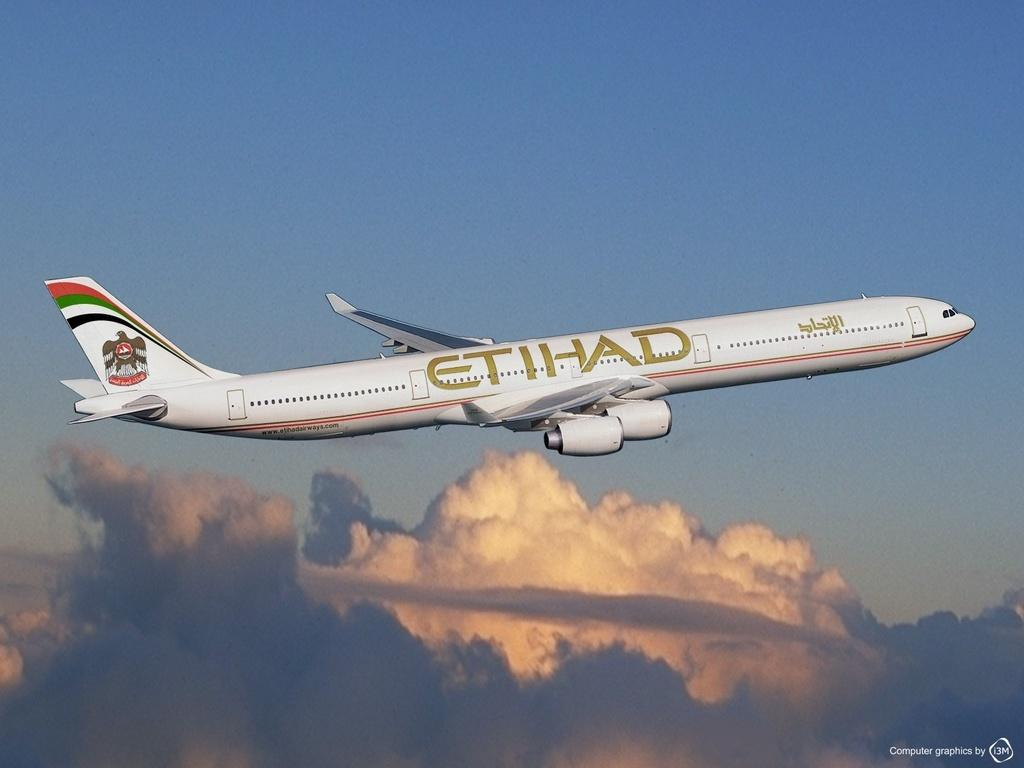What is the main subject of the image? The main subject of the image is an airplane flying. What can be seen in the background of the image? The sky is visible in the image, and there are clouds in the sky. Is there any text present in the image? Yes, there is text towards the bottom of the image. What type of meat is being cooked on the grill in the image? There is no grill or meat present in the image; it features an airplane flying in the sky. What is the cause of the fight between the two characters in the image? There are no characters or fight depicted in the image; it only shows an airplane flying in the sky. 